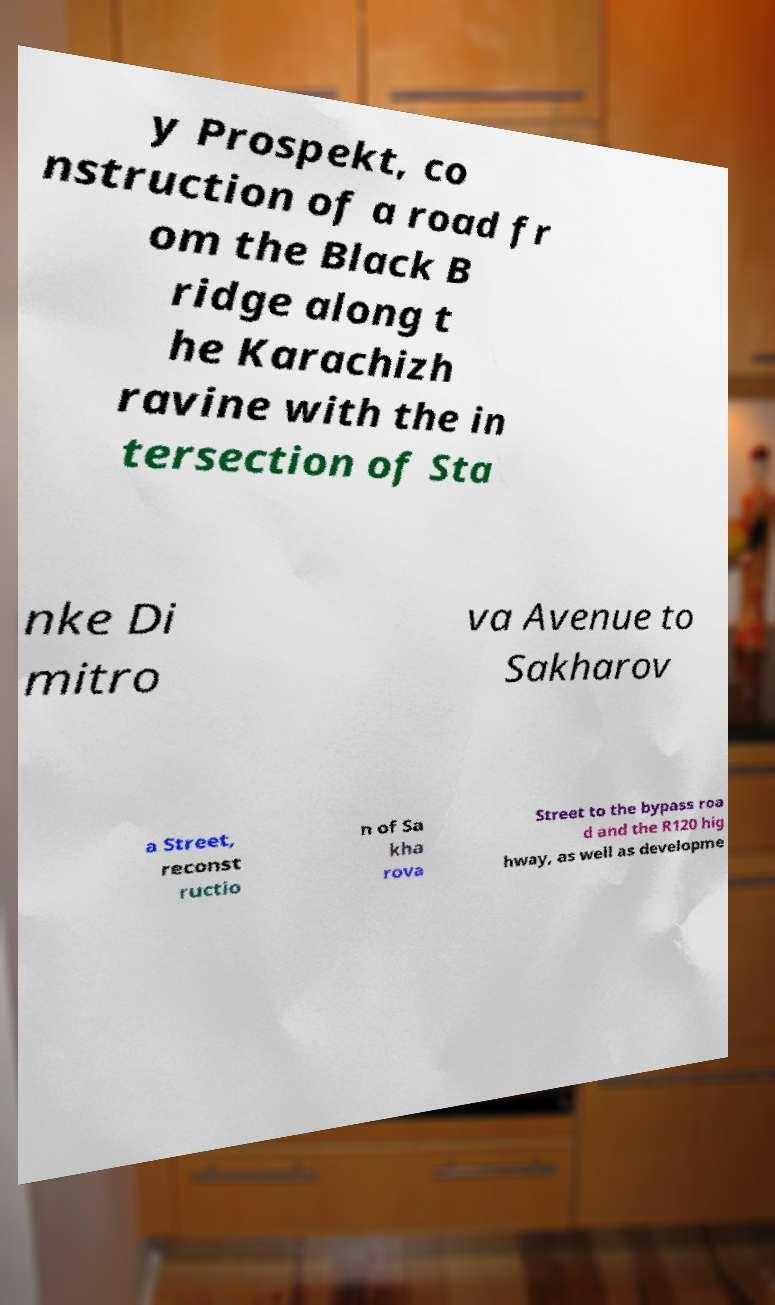What messages or text are displayed in this image? I need them in a readable, typed format. y Prospekt, co nstruction of a road fr om the Black B ridge along t he Karachizh ravine with the in tersection of Sta nke Di mitro va Avenue to Sakharov a Street, reconst ructio n of Sa kha rova Street to the bypass roa d and the R120 hig hway, as well as developme 